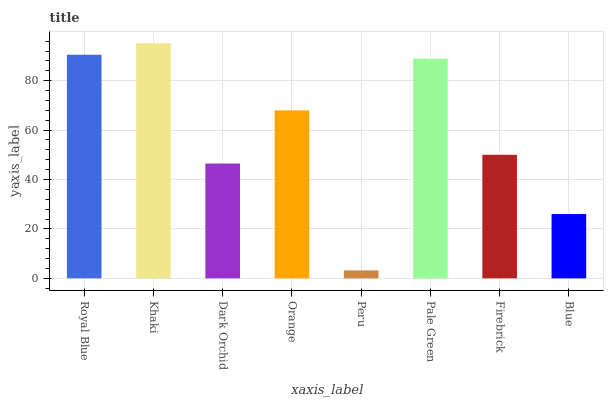Is Dark Orchid the minimum?
Answer yes or no. No. Is Dark Orchid the maximum?
Answer yes or no. No. Is Khaki greater than Dark Orchid?
Answer yes or no. Yes. Is Dark Orchid less than Khaki?
Answer yes or no. Yes. Is Dark Orchid greater than Khaki?
Answer yes or no. No. Is Khaki less than Dark Orchid?
Answer yes or no. No. Is Orange the high median?
Answer yes or no. Yes. Is Firebrick the low median?
Answer yes or no. Yes. Is Dark Orchid the high median?
Answer yes or no. No. Is Dark Orchid the low median?
Answer yes or no. No. 